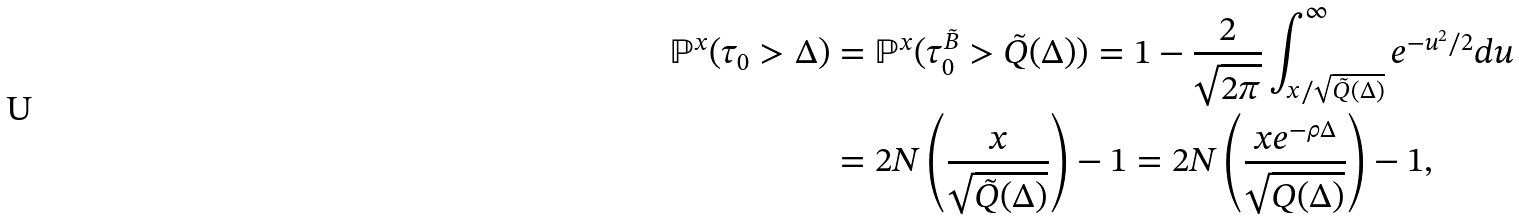Convert formula to latex. <formula><loc_0><loc_0><loc_500><loc_500>\mathbb { P } ^ { x } ( \tau _ { 0 } > \Delta ) & = \mathbb { P } ^ { x } ( \tau _ { 0 } ^ { \tilde { B } } > \tilde { Q } ( \Delta ) ) = 1 - \frac { 2 } { \sqrt { 2 \pi } } \int _ { x / \sqrt { \tilde { Q } ( \Delta ) } } ^ { \infty } e ^ { - u ^ { 2 } / 2 } d u \\ & = 2 N \left ( \frac { x } { \sqrt { \tilde { Q } ( \Delta ) } } \right ) - 1 = 2 N \left ( \frac { x e ^ { - \rho \Delta } } { \sqrt { Q ( \Delta ) } } \right ) - 1 ,</formula> 